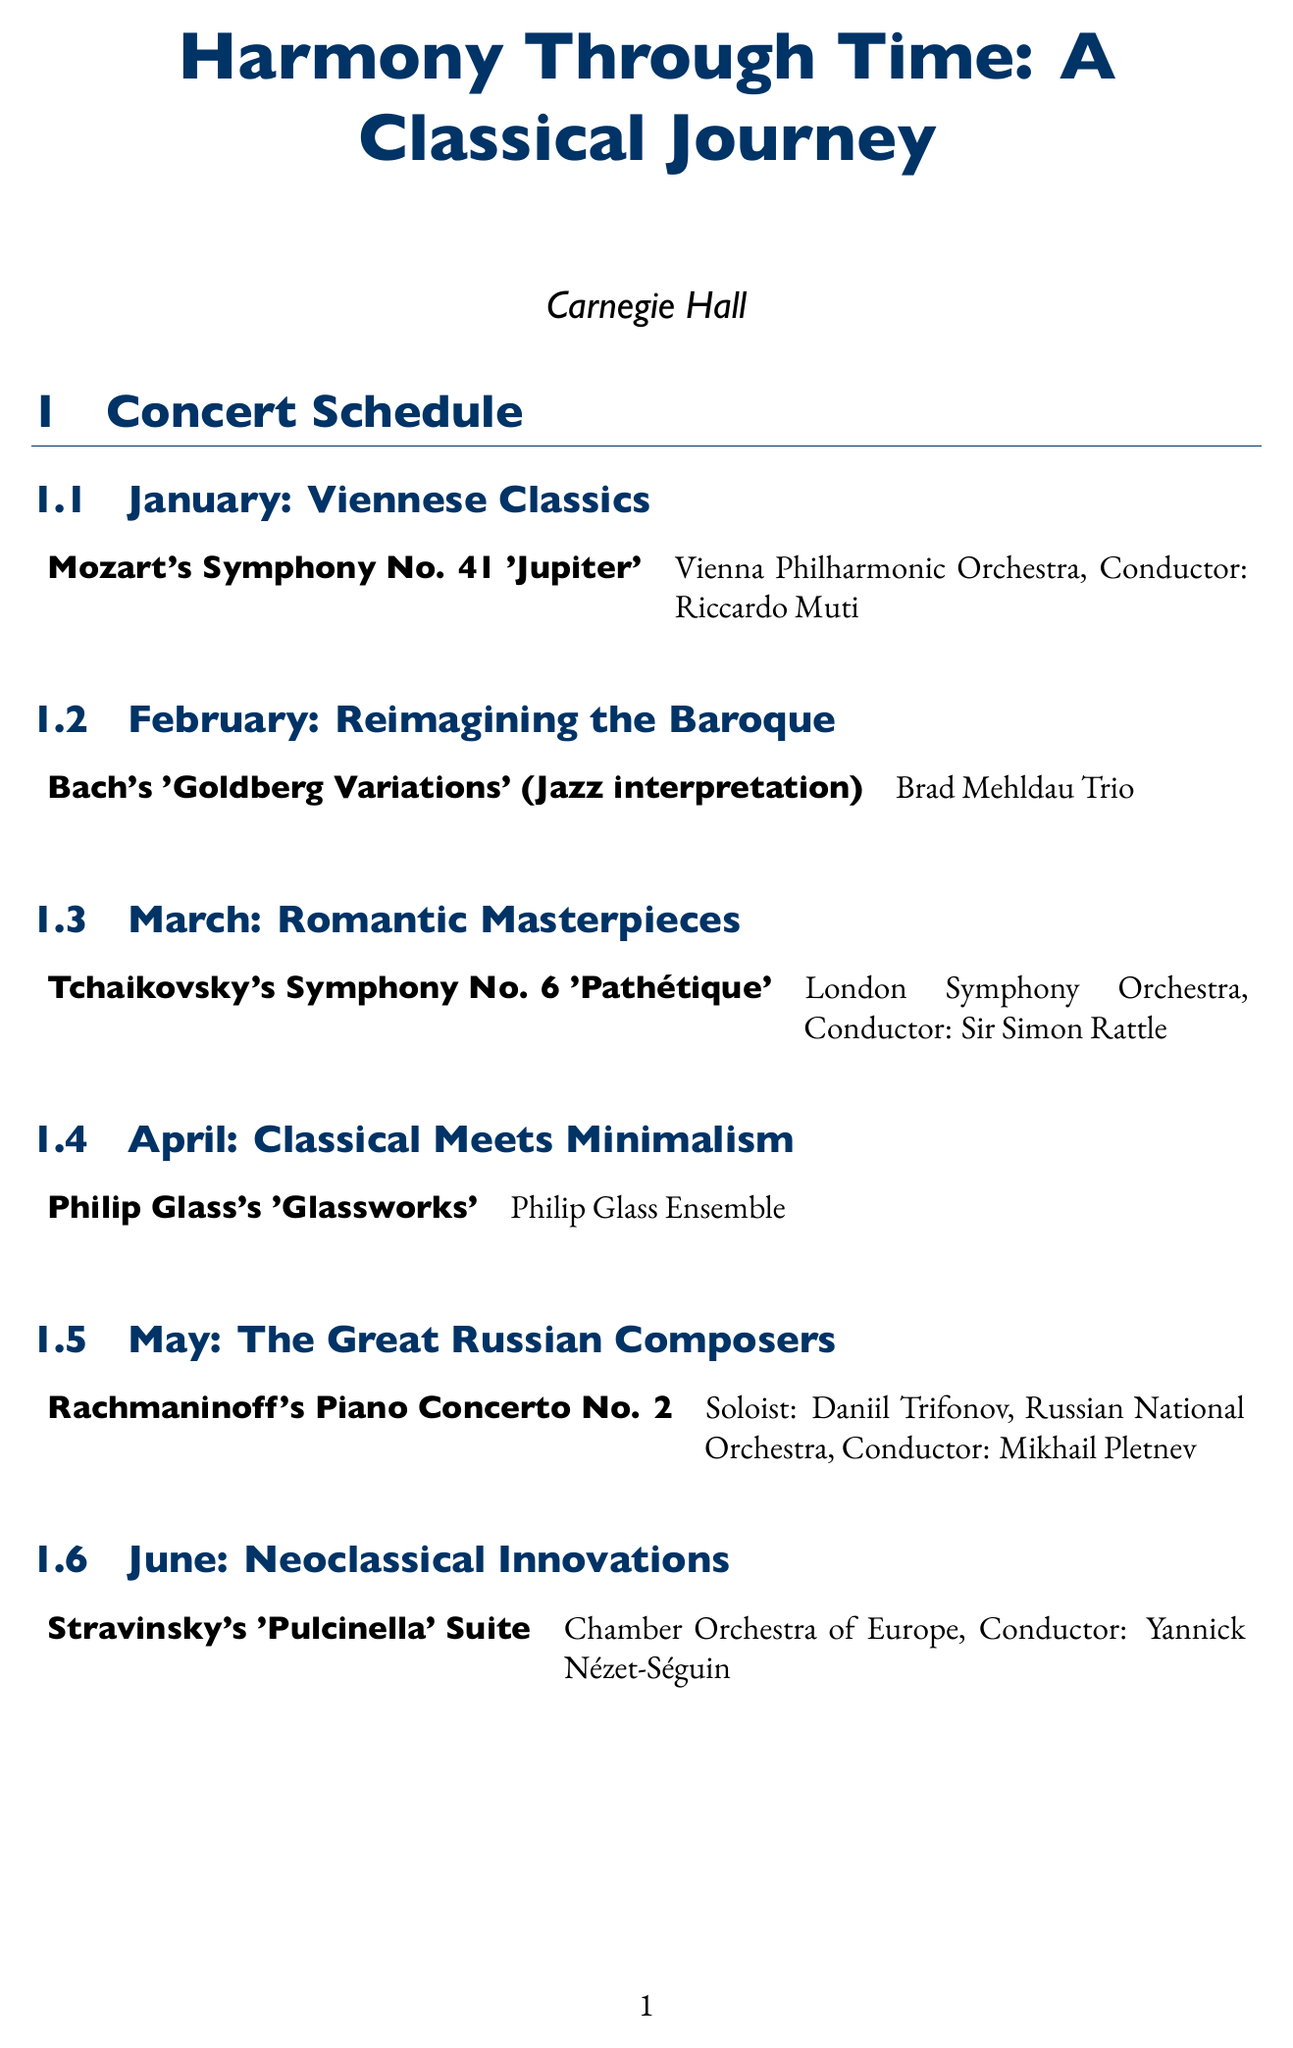What is the name of the concert series? The name of the concert series is stated at the beginning of the document.
Answer: Harmony Through Time: A Classical Journey Which month features the theme "Reimagining the Baroque"? The month is listed in the schedule section under the corresponding theme.
Answer: February Who is the soloist for Rachmaninoff's Piano Concerto No. 2? The performer is mentioned in the specific performance details for May.
Answer: Daniil Trifonov How much does a Full Series Subscription cost? The cost is found in the ticket options section of the document.
Answer: $600 What educational initiative offers pre-concert lectures? The description of the initiative is provided in the educational initiatives section.
Answer: Classical Conversations Which orchestra performs Tchaikovsky's Symphony No. 6? The performing ensemble is listed next to the performance title in the March schedule.
Answer: London Symphony Orchestra What benefit do Flex Pass holders receive? Benefits for ticket options are detailed in the corresponding section.
Answer: Choose any 4 concerts What is the audience engagement initiative that involves monthly polls? The initiative is specified in the audience engagement section of the document.
Answer: Traditional vs. Modern Survey 